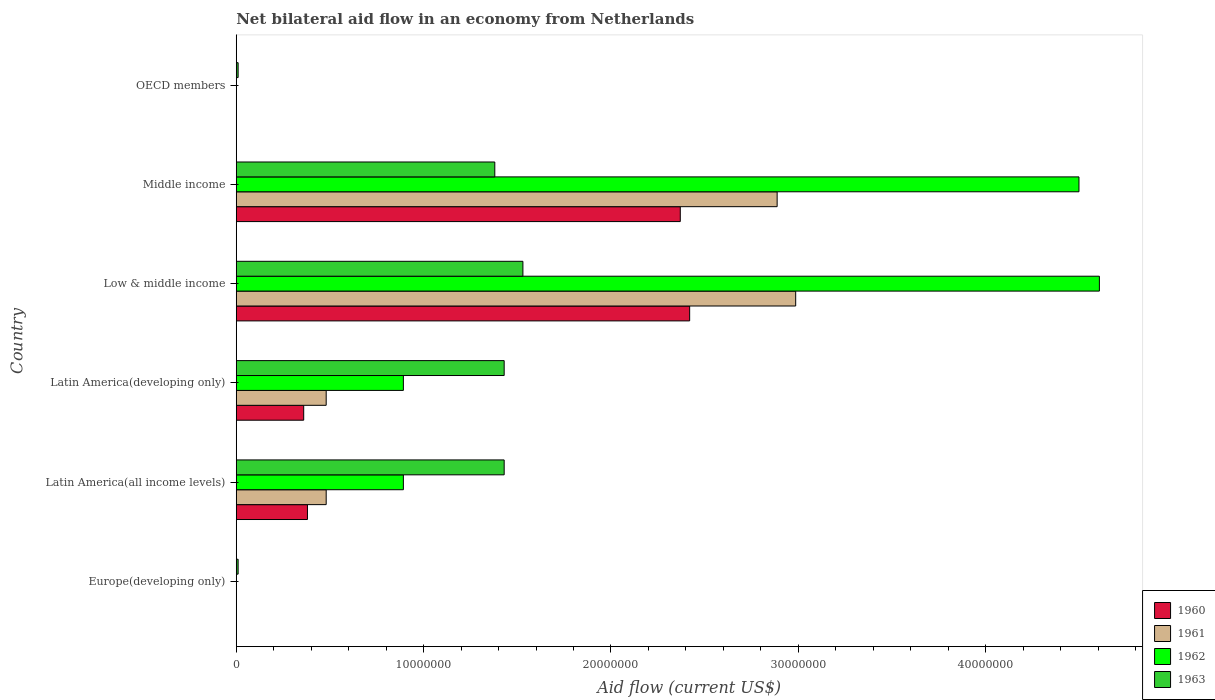How many different coloured bars are there?
Give a very brief answer. 4. Are the number of bars on each tick of the Y-axis equal?
Make the answer very short. No. How many bars are there on the 4th tick from the top?
Make the answer very short. 4. What is the label of the 4th group of bars from the top?
Offer a very short reply. Latin America(developing only). What is the net bilateral aid flow in 1961 in Latin America(all income levels)?
Ensure brevity in your answer.  4.80e+06. Across all countries, what is the maximum net bilateral aid flow in 1962?
Ensure brevity in your answer.  4.61e+07. In which country was the net bilateral aid flow in 1962 maximum?
Keep it short and to the point. Low & middle income. What is the total net bilateral aid flow in 1962 in the graph?
Offer a very short reply. 1.09e+08. What is the difference between the net bilateral aid flow in 1962 in Latin America(developing only) and that in Middle income?
Make the answer very short. -3.61e+07. What is the difference between the net bilateral aid flow in 1962 in Middle income and the net bilateral aid flow in 1963 in Low & middle income?
Ensure brevity in your answer.  2.97e+07. What is the average net bilateral aid flow in 1962 per country?
Your answer should be compact. 1.81e+07. What is the difference between the net bilateral aid flow in 1963 and net bilateral aid flow in 1961 in Middle income?
Make the answer very short. -1.51e+07. In how many countries, is the net bilateral aid flow in 1962 greater than 30000000 US$?
Offer a terse response. 2. What is the ratio of the net bilateral aid flow in 1960 in Low & middle income to that in Middle income?
Your response must be concise. 1.02. Is the net bilateral aid flow in 1960 in Latin America(all income levels) less than that in Latin America(developing only)?
Provide a short and direct response. No. What is the difference between the highest and the second highest net bilateral aid flow in 1961?
Keep it short and to the point. 9.90e+05. What is the difference between the highest and the lowest net bilateral aid flow in 1962?
Offer a very short reply. 4.61e+07. In how many countries, is the net bilateral aid flow in 1960 greater than the average net bilateral aid flow in 1960 taken over all countries?
Give a very brief answer. 2. Is the sum of the net bilateral aid flow in 1961 in Low & middle income and Middle income greater than the maximum net bilateral aid flow in 1963 across all countries?
Offer a very short reply. Yes. Is it the case that in every country, the sum of the net bilateral aid flow in 1962 and net bilateral aid flow in 1961 is greater than the net bilateral aid flow in 1963?
Provide a short and direct response. No. Are all the bars in the graph horizontal?
Your answer should be very brief. Yes. Are the values on the major ticks of X-axis written in scientific E-notation?
Provide a short and direct response. No. Does the graph contain grids?
Offer a very short reply. No. Where does the legend appear in the graph?
Give a very brief answer. Bottom right. How many legend labels are there?
Keep it short and to the point. 4. How are the legend labels stacked?
Ensure brevity in your answer.  Vertical. What is the title of the graph?
Your answer should be very brief. Net bilateral aid flow in an economy from Netherlands. Does "2009" appear as one of the legend labels in the graph?
Your answer should be very brief. No. What is the Aid flow (current US$) of 1960 in Europe(developing only)?
Offer a very short reply. 0. What is the Aid flow (current US$) in 1961 in Europe(developing only)?
Keep it short and to the point. 0. What is the Aid flow (current US$) of 1963 in Europe(developing only)?
Provide a short and direct response. 1.00e+05. What is the Aid flow (current US$) of 1960 in Latin America(all income levels)?
Ensure brevity in your answer.  3.80e+06. What is the Aid flow (current US$) of 1961 in Latin America(all income levels)?
Keep it short and to the point. 4.80e+06. What is the Aid flow (current US$) of 1962 in Latin America(all income levels)?
Your response must be concise. 8.92e+06. What is the Aid flow (current US$) of 1963 in Latin America(all income levels)?
Provide a succinct answer. 1.43e+07. What is the Aid flow (current US$) of 1960 in Latin America(developing only)?
Ensure brevity in your answer.  3.60e+06. What is the Aid flow (current US$) of 1961 in Latin America(developing only)?
Your answer should be very brief. 4.80e+06. What is the Aid flow (current US$) in 1962 in Latin America(developing only)?
Provide a succinct answer. 8.92e+06. What is the Aid flow (current US$) of 1963 in Latin America(developing only)?
Offer a terse response. 1.43e+07. What is the Aid flow (current US$) of 1960 in Low & middle income?
Your response must be concise. 2.42e+07. What is the Aid flow (current US$) of 1961 in Low & middle income?
Offer a terse response. 2.99e+07. What is the Aid flow (current US$) in 1962 in Low & middle income?
Provide a short and direct response. 4.61e+07. What is the Aid flow (current US$) of 1963 in Low & middle income?
Make the answer very short. 1.53e+07. What is the Aid flow (current US$) in 1960 in Middle income?
Ensure brevity in your answer.  2.37e+07. What is the Aid flow (current US$) of 1961 in Middle income?
Ensure brevity in your answer.  2.89e+07. What is the Aid flow (current US$) of 1962 in Middle income?
Your response must be concise. 4.50e+07. What is the Aid flow (current US$) of 1963 in Middle income?
Keep it short and to the point. 1.38e+07. What is the Aid flow (current US$) in 1960 in OECD members?
Ensure brevity in your answer.  0. What is the Aid flow (current US$) of 1962 in OECD members?
Give a very brief answer. 0. What is the Aid flow (current US$) in 1963 in OECD members?
Your answer should be very brief. 1.00e+05. Across all countries, what is the maximum Aid flow (current US$) of 1960?
Your answer should be compact. 2.42e+07. Across all countries, what is the maximum Aid flow (current US$) in 1961?
Your answer should be compact. 2.99e+07. Across all countries, what is the maximum Aid flow (current US$) of 1962?
Provide a succinct answer. 4.61e+07. Across all countries, what is the maximum Aid flow (current US$) in 1963?
Ensure brevity in your answer.  1.53e+07. Across all countries, what is the minimum Aid flow (current US$) in 1960?
Ensure brevity in your answer.  0. Across all countries, what is the minimum Aid flow (current US$) in 1962?
Your answer should be very brief. 0. What is the total Aid flow (current US$) of 1960 in the graph?
Provide a short and direct response. 5.53e+07. What is the total Aid flow (current US$) in 1961 in the graph?
Make the answer very short. 6.83e+07. What is the total Aid flow (current US$) of 1962 in the graph?
Your answer should be compact. 1.09e+08. What is the total Aid flow (current US$) of 1963 in the graph?
Offer a very short reply. 5.79e+07. What is the difference between the Aid flow (current US$) of 1963 in Europe(developing only) and that in Latin America(all income levels)?
Give a very brief answer. -1.42e+07. What is the difference between the Aid flow (current US$) in 1963 in Europe(developing only) and that in Latin America(developing only)?
Make the answer very short. -1.42e+07. What is the difference between the Aid flow (current US$) of 1963 in Europe(developing only) and that in Low & middle income?
Ensure brevity in your answer.  -1.52e+07. What is the difference between the Aid flow (current US$) in 1963 in Europe(developing only) and that in Middle income?
Provide a succinct answer. -1.37e+07. What is the difference between the Aid flow (current US$) of 1960 in Latin America(all income levels) and that in Low & middle income?
Keep it short and to the point. -2.04e+07. What is the difference between the Aid flow (current US$) in 1961 in Latin America(all income levels) and that in Low & middle income?
Your answer should be compact. -2.51e+07. What is the difference between the Aid flow (current US$) in 1962 in Latin America(all income levels) and that in Low & middle income?
Your response must be concise. -3.72e+07. What is the difference between the Aid flow (current US$) of 1963 in Latin America(all income levels) and that in Low & middle income?
Offer a terse response. -1.00e+06. What is the difference between the Aid flow (current US$) of 1960 in Latin America(all income levels) and that in Middle income?
Offer a terse response. -1.99e+07. What is the difference between the Aid flow (current US$) in 1961 in Latin America(all income levels) and that in Middle income?
Offer a terse response. -2.41e+07. What is the difference between the Aid flow (current US$) in 1962 in Latin America(all income levels) and that in Middle income?
Your answer should be compact. -3.61e+07. What is the difference between the Aid flow (current US$) in 1963 in Latin America(all income levels) and that in OECD members?
Keep it short and to the point. 1.42e+07. What is the difference between the Aid flow (current US$) in 1960 in Latin America(developing only) and that in Low & middle income?
Your answer should be very brief. -2.06e+07. What is the difference between the Aid flow (current US$) in 1961 in Latin America(developing only) and that in Low & middle income?
Ensure brevity in your answer.  -2.51e+07. What is the difference between the Aid flow (current US$) of 1962 in Latin America(developing only) and that in Low & middle income?
Offer a very short reply. -3.72e+07. What is the difference between the Aid flow (current US$) in 1960 in Latin America(developing only) and that in Middle income?
Ensure brevity in your answer.  -2.01e+07. What is the difference between the Aid flow (current US$) of 1961 in Latin America(developing only) and that in Middle income?
Your response must be concise. -2.41e+07. What is the difference between the Aid flow (current US$) in 1962 in Latin America(developing only) and that in Middle income?
Your answer should be compact. -3.61e+07. What is the difference between the Aid flow (current US$) in 1963 in Latin America(developing only) and that in OECD members?
Provide a succinct answer. 1.42e+07. What is the difference between the Aid flow (current US$) of 1961 in Low & middle income and that in Middle income?
Provide a short and direct response. 9.90e+05. What is the difference between the Aid flow (current US$) in 1962 in Low & middle income and that in Middle income?
Your response must be concise. 1.09e+06. What is the difference between the Aid flow (current US$) of 1963 in Low & middle income and that in Middle income?
Offer a very short reply. 1.50e+06. What is the difference between the Aid flow (current US$) of 1963 in Low & middle income and that in OECD members?
Your answer should be very brief. 1.52e+07. What is the difference between the Aid flow (current US$) in 1963 in Middle income and that in OECD members?
Keep it short and to the point. 1.37e+07. What is the difference between the Aid flow (current US$) of 1960 in Latin America(all income levels) and the Aid flow (current US$) of 1962 in Latin America(developing only)?
Provide a short and direct response. -5.12e+06. What is the difference between the Aid flow (current US$) in 1960 in Latin America(all income levels) and the Aid flow (current US$) in 1963 in Latin America(developing only)?
Ensure brevity in your answer.  -1.05e+07. What is the difference between the Aid flow (current US$) in 1961 in Latin America(all income levels) and the Aid flow (current US$) in 1962 in Latin America(developing only)?
Make the answer very short. -4.12e+06. What is the difference between the Aid flow (current US$) in 1961 in Latin America(all income levels) and the Aid flow (current US$) in 1963 in Latin America(developing only)?
Provide a short and direct response. -9.50e+06. What is the difference between the Aid flow (current US$) of 1962 in Latin America(all income levels) and the Aid flow (current US$) of 1963 in Latin America(developing only)?
Keep it short and to the point. -5.38e+06. What is the difference between the Aid flow (current US$) of 1960 in Latin America(all income levels) and the Aid flow (current US$) of 1961 in Low & middle income?
Give a very brief answer. -2.61e+07. What is the difference between the Aid flow (current US$) in 1960 in Latin America(all income levels) and the Aid flow (current US$) in 1962 in Low & middle income?
Provide a succinct answer. -4.23e+07. What is the difference between the Aid flow (current US$) in 1960 in Latin America(all income levels) and the Aid flow (current US$) in 1963 in Low & middle income?
Keep it short and to the point. -1.15e+07. What is the difference between the Aid flow (current US$) in 1961 in Latin America(all income levels) and the Aid flow (current US$) in 1962 in Low & middle income?
Ensure brevity in your answer.  -4.13e+07. What is the difference between the Aid flow (current US$) in 1961 in Latin America(all income levels) and the Aid flow (current US$) in 1963 in Low & middle income?
Provide a short and direct response. -1.05e+07. What is the difference between the Aid flow (current US$) in 1962 in Latin America(all income levels) and the Aid flow (current US$) in 1963 in Low & middle income?
Make the answer very short. -6.38e+06. What is the difference between the Aid flow (current US$) in 1960 in Latin America(all income levels) and the Aid flow (current US$) in 1961 in Middle income?
Give a very brief answer. -2.51e+07. What is the difference between the Aid flow (current US$) in 1960 in Latin America(all income levels) and the Aid flow (current US$) in 1962 in Middle income?
Keep it short and to the point. -4.12e+07. What is the difference between the Aid flow (current US$) of 1960 in Latin America(all income levels) and the Aid flow (current US$) of 1963 in Middle income?
Provide a short and direct response. -1.00e+07. What is the difference between the Aid flow (current US$) in 1961 in Latin America(all income levels) and the Aid flow (current US$) in 1962 in Middle income?
Your answer should be very brief. -4.02e+07. What is the difference between the Aid flow (current US$) in 1961 in Latin America(all income levels) and the Aid flow (current US$) in 1963 in Middle income?
Offer a terse response. -9.00e+06. What is the difference between the Aid flow (current US$) of 1962 in Latin America(all income levels) and the Aid flow (current US$) of 1963 in Middle income?
Provide a succinct answer. -4.88e+06. What is the difference between the Aid flow (current US$) of 1960 in Latin America(all income levels) and the Aid flow (current US$) of 1963 in OECD members?
Offer a very short reply. 3.70e+06. What is the difference between the Aid flow (current US$) of 1961 in Latin America(all income levels) and the Aid flow (current US$) of 1963 in OECD members?
Provide a succinct answer. 4.70e+06. What is the difference between the Aid flow (current US$) in 1962 in Latin America(all income levels) and the Aid flow (current US$) in 1963 in OECD members?
Your answer should be compact. 8.82e+06. What is the difference between the Aid flow (current US$) in 1960 in Latin America(developing only) and the Aid flow (current US$) in 1961 in Low & middle income?
Provide a succinct answer. -2.63e+07. What is the difference between the Aid flow (current US$) in 1960 in Latin America(developing only) and the Aid flow (current US$) in 1962 in Low & middle income?
Give a very brief answer. -4.25e+07. What is the difference between the Aid flow (current US$) in 1960 in Latin America(developing only) and the Aid flow (current US$) in 1963 in Low & middle income?
Offer a terse response. -1.17e+07. What is the difference between the Aid flow (current US$) of 1961 in Latin America(developing only) and the Aid flow (current US$) of 1962 in Low & middle income?
Offer a very short reply. -4.13e+07. What is the difference between the Aid flow (current US$) in 1961 in Latin America(developing only) and the Aid flow (current US$) in 1963 in Low & middle income?
Make the answer very short. -1.05e+07. What is the difference between the Aid flow (current US$) of 1962 in Latin America(developing only) and the Aid flow (current US$) of 1963 in Low & middle income?
Your answer should be very brief. -6.38e+06. What is the difference between the Aid flow (current US$) of 1960 in Latin America(developing only) and the Aid flow (current US$) of 1961 in Middle income?
Keep it short and to the point. -2.53e+07. What is the difference between the Aid flow (current US$) of 1960 in Latin America(developing only) and the Aid flow (current US$) of 1962 in Middle income?
Your answer should be very brief. -4.14e+07. What is the difference between the Aid flow (current US$) in 1960 in Latin America(developing only) and the Aid flow (current US$) in 1963 in Middle income?
Offer a terse response. -1.02e+07. What is the difference between the Aid flow (current US$) in 1961 in Latin America(developing only) and the Aid flow (current US$) in 1962 in Middle income?
Offer a terse response. -4.02e+07. What is the difference between the Aid flow (current US$) of 1961 in Latin America(developing only) and the Aid flow (current US$) of 1963 in Middle income?
Provide a succinct answer. -9.00e+06. What is the difference between the Aid flow (current US$) of 1962 in Latin America(developing only) and the Aid flow (current US$) of 1963 in Middle income?
Ensure brevity in your answer.  -4.88e+06. What is the difference between the Aid flow (current US$) of 1960 in Latin America(developing only) and the Aid flow (current US$) of 1963 in OECD members?
Your answer should be compact. 3.50e+06. What is the difference between the Aid flow (current US$) of 1961 in Latin America(developing only) and the Aid flow (current US$) of 1963 in OECD members?
Your answer should be compact. 4.70e+06. What is the difference between the Aid flow (current US$) in 1962 in Latin America(developing only) and the Aid flow (current US$) in 1963 in OECD members?
Offer a very short reply. 8.82e+06. What is the difference between the Aid flow (current US$) in 1960 in Low & middle income and the Aid flow (current US$) in 1961 in Middle income?
Give a very brief answer. -4.67e+06. What is the difference between the Aid flow (current US$) of 1960 in Low & middle income and the Aid flow (current US$) of 1962 in Middle income?
Your answer should be very brief. -2.08e+07. What is the difference between the Aid flow (current US$) in 1960 in Low & middle income and the Aid flow (current US$) in 1963 in Middle income?
Provide a short and direct response. 1.04e+07. What is the difference between the Aid flow (current US$) in 1961 in Low & middle income and the Aid flow (current US$) in 1962 in Middle income?
Ensure brevity in your answer.  -1.51e+07. What is the difference between the Aid flow (current US$) of 1961 in Low & middle income and the Aid flow (current US$) of 1963 in Middle income?
Provide a succinct answer. 1.61e+07. What is the difference between the Aid flow (current US$) in 1962 in Low & middle income and the Aid flow (current US$) in 1963 in Middle income?
Ensure brevity in your answer.  3.23e+07. What is the difference between the Aid flow (current US$) of 1960 in Low & middle income and the Aid flow (current US$) of 1963 in OECD members?
Your response must be concise. 2.41e+07. What is the difference between the Aid flow (current US$) in 1961 in Low & middle income and the Aid flow (current US$) in 1963 in OECD members?
Your answer should be compact. 2.98e+07. What is the difference between the Aid flow (current US$) of 1962 in Low & middle income and the Aid flow (current US$) of 1963 in OECD members?
Your answer should be compact. 4.60e+07. What is the difference between the Aid flow (current US$) of 1960 in Middle income and the Aid flow (current US$) of 1963 in OECD members?
Your answer should be compact. 2.36e+07. What is the difference between the Aid flow (current US$) of 1961 in Middle income and the Aid flow (current US$) of 1963 in OECD members?
Your answer should be compact. 2.88e+07. What is the difference between the Aid flow (current US$) of 1962 in Middle income and the Aid flow (current US$) of 1963 in OECD members?
Offer a very short reply. 4.49e+07. What is the average Aid flow (current US$) in 1960 per country?
Ensure brevity in your answer.  9.22e+06. What is the average Aid flow (current US$) in 1961 per country?
Keep it short and to the point. 1.14e+07. What is the average Aid flow (current US$) of 1962 per country?
Provide a succinct answer. 1.81e+07. What is the average Aid flow (current US$) of 1963 per country?
Ensure brevity in your answer.  9.65e+06. What is the difference between the Aid flow (current US$) of 1960 and Aid flow (current US$) of 1962 in Latin America(all income levels)?
Provide a succinct answer. -5.12e+06. What is the difference between the Aid flow (current US$) in 1960 and Aid flow (current US$) in 1963 in Latin America(all income levels)?
Offer a terse response. -1.05e+07. What is the difference between the Aid flow (current US$) in 1961 and Aid flow (current US$) in 1962 in Latin America(all income levels)?
Provide a succinct answer. -4.12e+06. What is the difference between the Aid flow (current US$) in 1961 and Aid flow (current US$) in 1963 in Latin America(all income levels)?
Your answer should be compact. -9.50e+06. What is the difference between the Aid flow (current US$) in 1962 and Aid flow (current US$) in 1963 in Latin America(all income levels)?
Provide a succinct answer. -5.38e+06. What is the difference between the Aid flow (current US$) in 1960 and Aid flow (current US$) in 1961 in Latin America(developing only)?
Offer a terse response. -1.20e+06. What is the difference between the Aid flow (current US$) in 1960 and Aid flow (current US$) in 1962 in Latin America(developing only)?
Offer a very short reply. -5.32e+06. What is the difference between the Aid flow (current US$) of 1960 and Aid flow (current US$) of 1963 in Latin America(developing only)?
Your answer should be compact. -1.07e+07. What is the difference between the Aid flow (current US$) in 1961 and Aid flow (current US$) in 1962 in Latin America(developing only)?
Make the answer very short. -4.12e+06. What is the difference between the Aid flow (current US$) in 1961 and Aid flow (current US$) in 1963 in Latin America(developing only)?
Provide a short and direct response. -9.50e+06. What is the difference between the Aid flow (current US$) of 1962 and Aid flow (current US$) of 1963 in Latin America(developing only)?
Keep it short and to the point. -5.38e+06. What is the difference between the Aid flow (current US$) in 1960 and Aid flow (current US$) in 1961 in Low & middle income?
Keep it short and to the point. -5.66e+06. What is the difference between the Aid flow (current US$) in 1960 and Aid flow (current US$) in 1962 in Low & middle income?
Your answer should be very brief. -2.19e+07. What is the difference between the Aid flow (current US$) in 1960 and Aid flow (current US$) in 1963 in Low & middle income?
Keep it short and to the point. 8.90e+06. What is the difference between the Aid flow (current US$) in 1961 and Aid flow (current US$) in 1962 in Low & middle income?
Ensure brevity in your answer.  -1.62e+07. What is the difference between the Aid flow (current US$) of 1961 and Aid flow (current US$) of 1963 in Low & middle income?
Make the answer very short. 1.46e+07. What is the difference between the Aid flow (current US$) in 1962 and Aid flow (current US$) in 1963 in Low & middle income?
Your answer should be compact. 3.08e+07. What is the difference between the Aid flow (current US$) of 1960 and Aid flow (current US$) of 1961 in Middle income?
Provide a succinct answer. -5.17e+06. What is the difference between the Aid flow (current US$) in 1960 and Aid flow (current US$) in 1962 in Middle income?
Keep it short and to the point. -2.13e+07. What is the difference between the Aid flow (current US$) of 1960 and Aid flow (current US$) of 1963 in Middle income?
Make the answer very short. 9.90e+06. What is the difference between the Aid flow (current US$) in 1961 and Aid flow (current US$) in 1962 in Middle income?
Keep it short and to the point. -1.61e+07. What is the difference between the Aid flow (current US$) in 1961 and Aid flow (current US$) in 1963 in Middle income?
Provide a short and direct response. 1.51e+07. What is the difference between the Aid flow (current US$) of 1962 and Aid flow (current US$) of 1963 in Middle income?
Offer a terse response. 3.12e+07. What is the ratio of the Aid flow (current US$) in 1963 in Europe(developing only) to that in Latin America(all income levels)?
Offer a terse response. 0.01. What is the ratio of the Aid flow (current US$) in 1963 in Europe(developing only) to that in Latin America(developing only)?
Your answer should be compact. 0.01. What is the ratio of the Aid flow (current US$) in 1963 in Europe(developing only) to that in Low & middle income?
Ensure brevity in your answer.  0.01. What is the ratio of the Aid flow (current US$) in 1963 in Europe(developing only) to that in Middle income?
Offer a terse response. 0.01. What is the ratio of the Aid flow (current US$) of 1960 in Latin America(all income levels) to that in Latin America(developing only)?
Keep it short and to the point. 1.06. What is the ratio of the Aid flow (current US$) in 1961 in Latin America(all income levels) to that in Latin America(developing only)?
Ensure brevity in your answer.  1. What is the ratio of the Aid flow (current US$) in 1960 in Latin America(all income levels) to that in Low & middle income?
Your answer should be very brief. 0.16. What is the ratio of the Aid flow (current US$) in 1961 in Latin America(all income levels) to that in Low & middle income?
Provide a short and direct response. 0.16. What is the ratio of the Aid flow (current US$) in 1962 in Latin America(all income levels) to that in Low & middle income?
Your answer should be compact. 0.19. What is the ratio of the Aid flow (current US$) of 1963 in Latin America(all income levels) to that in Low & middle income?
Make the answer very short. 0.93. What is the ratio of the Aid flow (current US$) of 1960 in Latin America(all income levels) to that in Middle income?
Provide a short and direct response. 0.16. What is the ratio of the Aid flow (current US$) in 1961 in Latin America(all income levels) to that in Middle income?
Ensure brevity in your answer.  0.17. What is the ratio of the Aid flow (current US$) in 1962 in Latin America(all income levels) to that in Middle income?
Keep it short and to the point. 0.2. What is the ratio of the Aid flow (current US$) of 1963 in Latin America(all income levels) to that in Middle income?
Your response must be concise. 1.04. What is the ratio of the Aid flow (current US$) of 1963 in Latin America(all income levels) to that in OECD members?
Provide a short and direct response. 143. What is the ratio of the Aid flow (current US$) in 1960 in Latin America(developing only) to that in Low & middle income?
Offer a very short reply. 0.15. What is the ratio of the Aid flow (current US$) in 1961 in Latin America(developing only) to that in Low & middle income?
Ensure brevity in your answer.  0.16. What is the ratio of the Aid flow (current US$) in 1962 in Latin America(developing only) to that in Low & middle income?
Give a very brief answer. 0.19. What is the ratio of the Aid flow (current US$) in 1963 in Latin America(developing only) to that in Low & middle income?
Provide a succinct answer. 0.93. What is the ratio of the Aid flow (current US$) of 1960 in Latin America(developing only) to that in Middle income?
Your response must be concise. 0.15. What is the ratio of the Aid flow (current US$) of 1961 in Latin America(developing only) to that in Middle income?
Keep it short and to the point. 0.17. What is the ratio of the Aid flow (current US$) of 1962 in Latin America(developing only) to that in Middle income?
Your answer should be compact. 0.2. What is the ratio of the Aid flow (current US$) of 1963 in Latin America(developing only) to that in Middle income?
Ensure brevity in your answer.  1.04. What is the ratio of the Aid flow (current US$) of 1963 in Latin America(developing only) to that in OECD members?
Your answer should be compact. 143. What is the ratio of the Aid flow (current US$) in 1960 in Low & middle income to that in Middle income?
Keep it short and to the point. 1.02. What is the ratio of the Aid flow (current US$) of 1961 in Low & middle income to that in Middle income?
Keep it short and to the point. 1.03. What is the ratio of the Aid flow (current US$) of 1962 in Low & middle income to that in Middle income?
Provide a short and direct response. 1.02. What is the ratio of the Aid flow (current US$) of 1963 in Low & middle income to that in Middle income?
Provide a succinct answer. 1.11. What is the ratio of the Aid flow (current US$) of 1963 in Low & middle income to that in OECD members?
Keep it short and to the point. 153. What is the ratio of the Aid flow (current US$) in 1963 in Middle income to that in OECD members?
Provide a succinct answer. 138. What is the difference between the highest and the second highest Aid flow (current US$) of 1961?
Your answer should be very brief. 9.90e+05. What is the difference between the highest and the second highest Aid flow (current US$) in 1962?
Keep it short and to the point. 1.09e+06. What is the difference between the highest and the lowest Aid flow (current US$) in 1960?
Your answer should be very brief. 2.42e+07. What is the difference between the highest and the lowest Aid flow (current US$) of 1961?
Provide a short and direct response. 2.99e+07. What is the difference between the highest and the lowest Aid flow (current US$) in 1962?
Provide a succinct answer. 4.61e+07. What is the difference between the highest and the lowest Aid flow (current US$) in 1963?
Your answer should be very brief. 1.52e+07. 